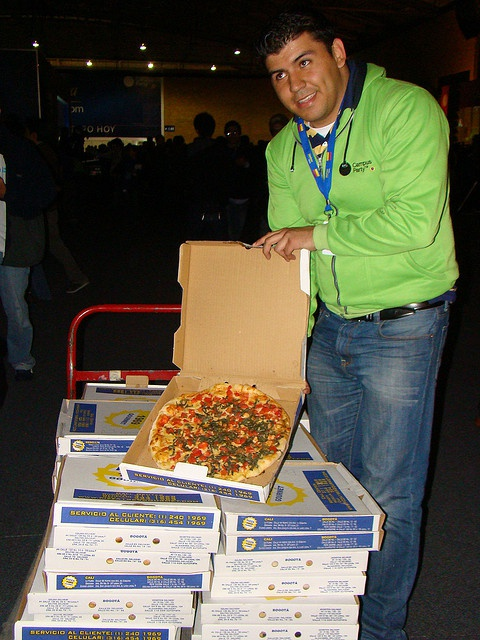Describe the objects in this image and their specific colors. I can see people in black, lightgreen, gray, blue, and navy tones, pizza in black, brown, orange, olive, and red tones, people in black, gray, and purple tones, people in black, maroon, navy, and teal tones, and people in black, darkgreen, and gray tones in this image. 